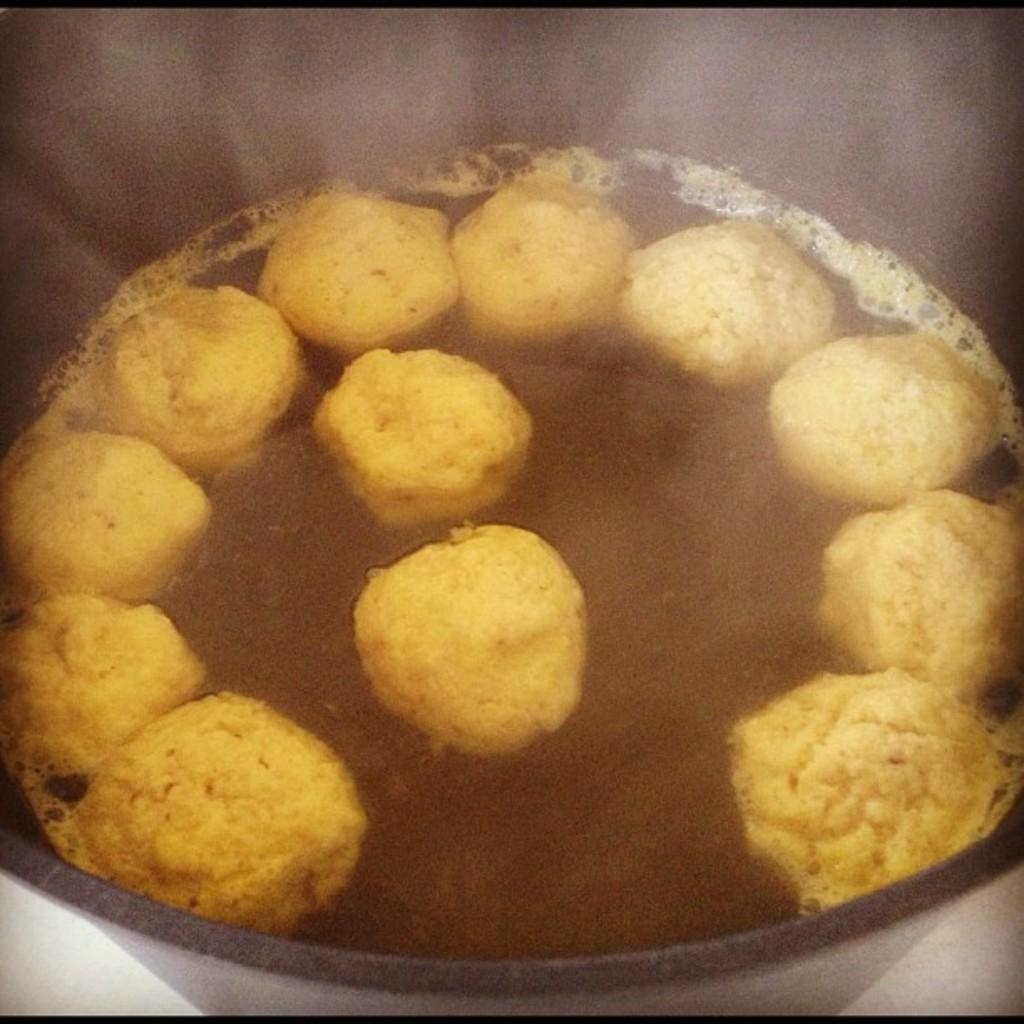What is present in the image? There is a bowl in the image. What is inside the bowl? There is a food item in the bowl. What type of caption is written on the bowl in the image? There is no caption written on the bowl in the image. How many ladybugs can be seen crawling on the food item in the image? There are no ladybugs present in the image. 